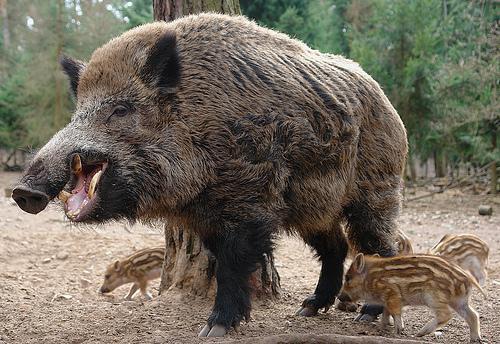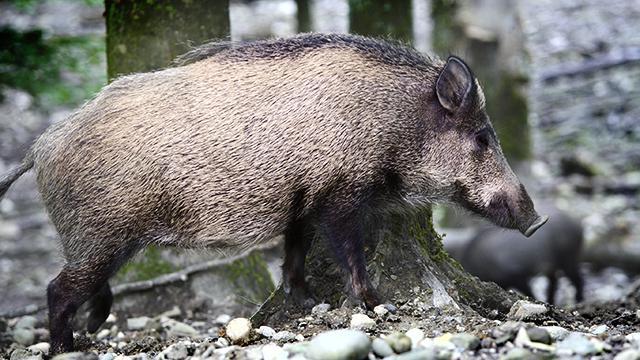The first image is the image on the left, the second image is the image on the right. For the images displayed, is the sentence "An animals is walking with its babies." factually correct? Answer yes or no. Yes. 